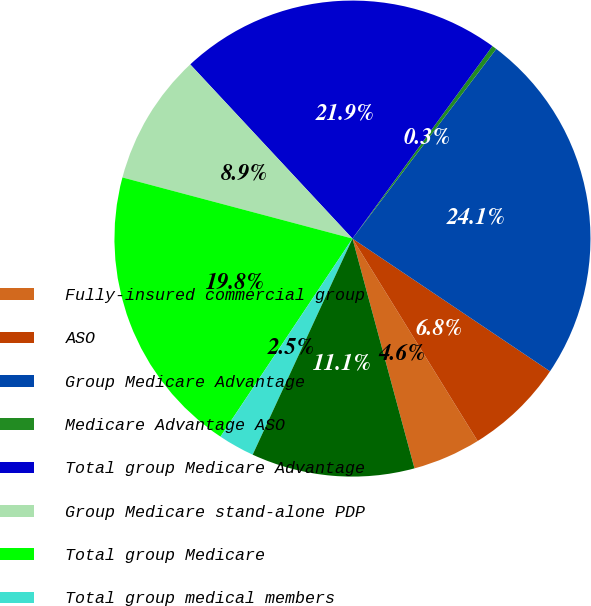Convert chart to OTSL. <chart><loc_0><loc_0><loc_500><loc_500><pie_chart><fcel>Fully-insured commercial group<fcel>ASO<fcel>Group Medicare Advantage<fcel>Medicare Advantage ASO<fcel>Total group Medicare Advantage<fcel>Group Medicare stand-alone PDP<fcel>Total group Medicare<fcel>Total group medical members<fcel>Group specialty membership (a)<nl><fcel>4.62%<fcel>6.77%<fcel>24.09%<fcel>0.32%<fcel>21.94%<fcel>8.93%<fcel>19.78%<fcel>2.47%<fcel>11.08%<nl></chart> 